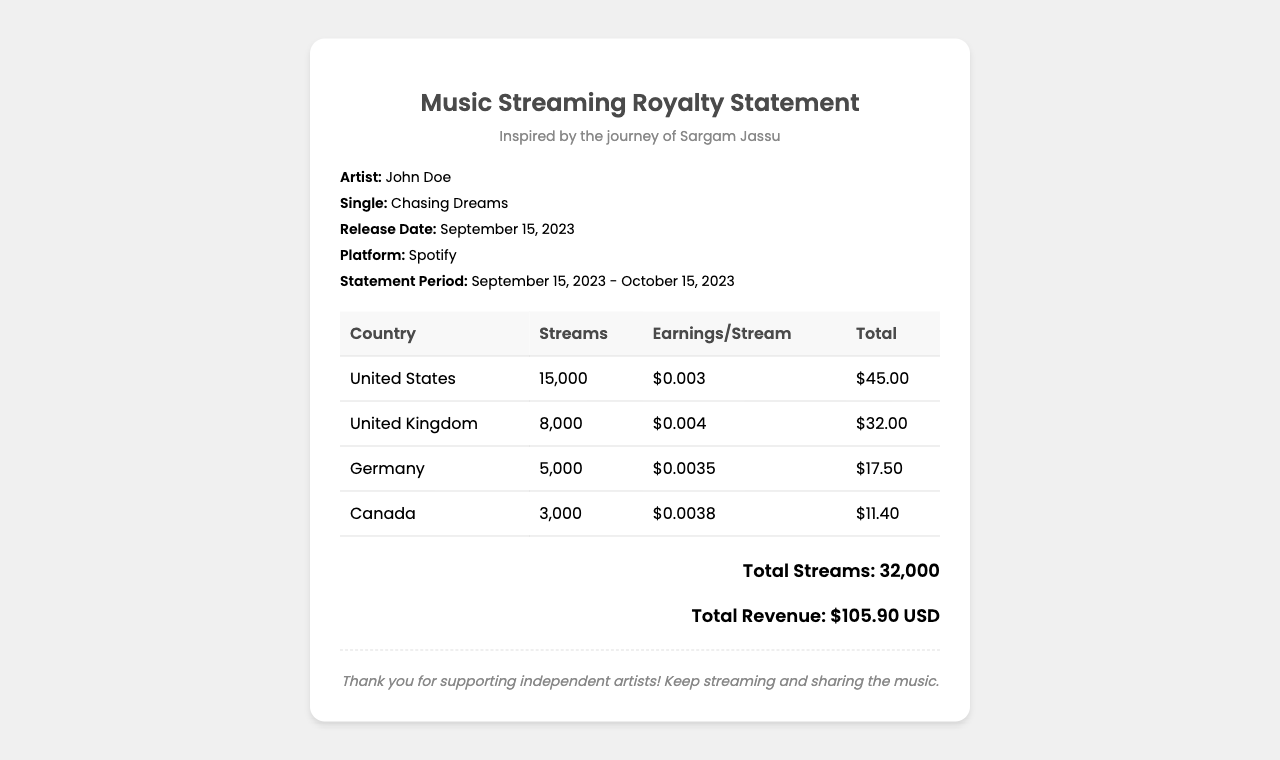What is the artist's name? The artist's name is mentioned under the "Artist" section of the document.
Answer: John Doe What is the single's title? The title of the single can be found in the "Single" section of the document.
Answer: Chasing Dreams How many streams were recorded in Germany? The number of streams in Germany is displayed in the corresponding table row.
Answer: 5000 What is the earnings per stream for the United Kingdom? The earnings per stream for the United Kingdom is listed in the table.
Answer: $0.004 What is the total revenue earned? The total revenue is stated in the summary at the bottom of the document.
Answer: $105.90 USD What was the statement period? The statement period is clearly indicated in the details section of the document.
Answer: September 15, 2023 - October 15, 2023 Which country had the highest number of streams? By comparing the stream counts in the table, the country with the highest number can be determined.
Answer: United States How many countries are listed in the table? The number of unique countries represented in the table can be counted.
Answer: 4 How much did the artist earn from streams in Canada? The total earnings from streams in Canada can be found in the table.
Answer: $11.40 